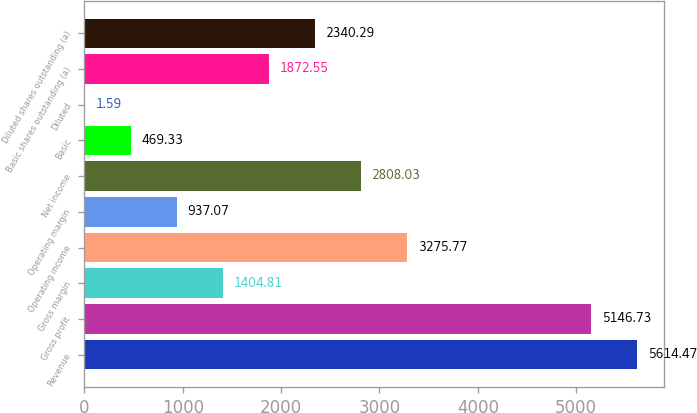Convert chart to OTSL. <chart><loc_0><loc_0><loc_500><loc_500><bar_chart><fcel>Revenue<fcel>Gross profit<fcel>Gross margin<fcel>Operating income<fcel>Operating margin<fcel>Net income<fcel>Basic<fcel>Diluted<fcel>Basic shares outstanding (a)<fcel>Diluted shares outstanding (a)<nl><fcel>5614.47<fcel>5146.73<fcel>1404.81<fcel>3275.77<fcel>937.07<fcel>2808.03<fcel>469.33<fcel>1.59<fcel>1872.55<fcel>2340.29<nl></chart> 